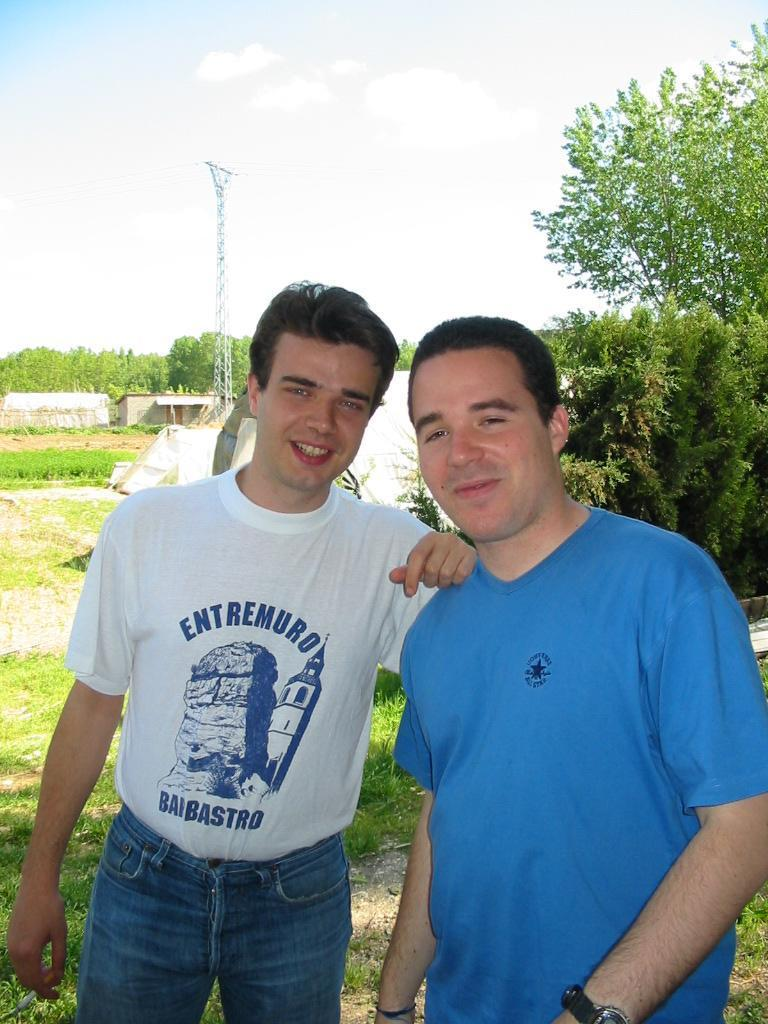How many people are in the image? There are two people in the image. What are the people doing in the image? The people are smiling and standing. What type of vegetation is the ground is covered with in the image? There is green grass in the image. What other objects can be seen in the image? There is an electric pole and trees in the image. What type of stew is being prepared by the farmer in the image? There is no farmer or stew present in the image. What type of land can be seen in the image? The image does not specifically mention the type of land; it only shows green grass, an electric pole. 